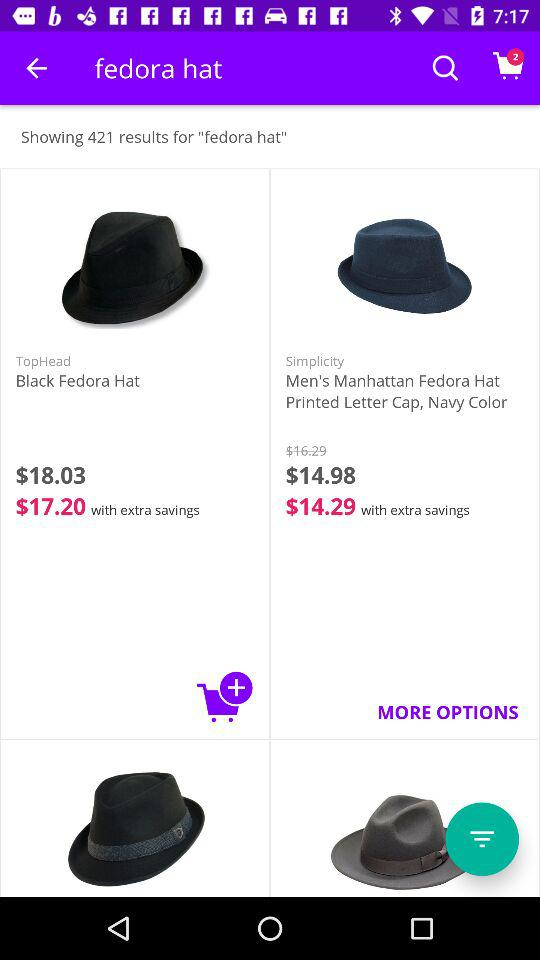What is the number of items added to the cart? The number of items is 2. 